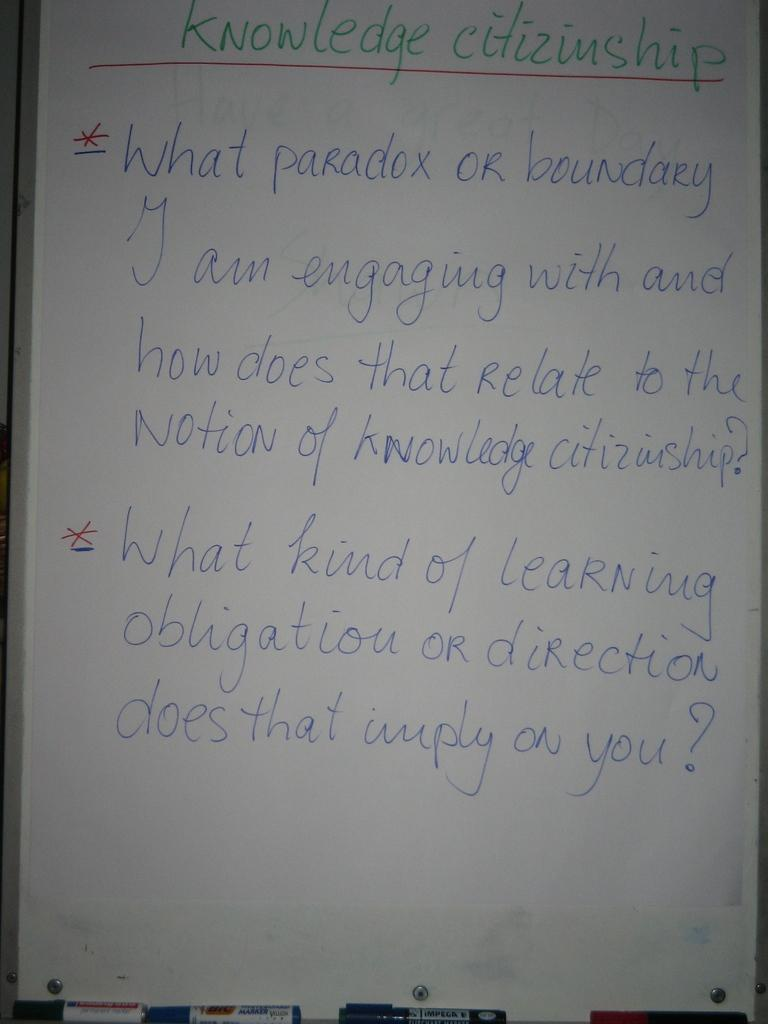<image>
Write a terse but informative summary of the picture. A whiteboard with Knowledge Citizenship written in green marker. 